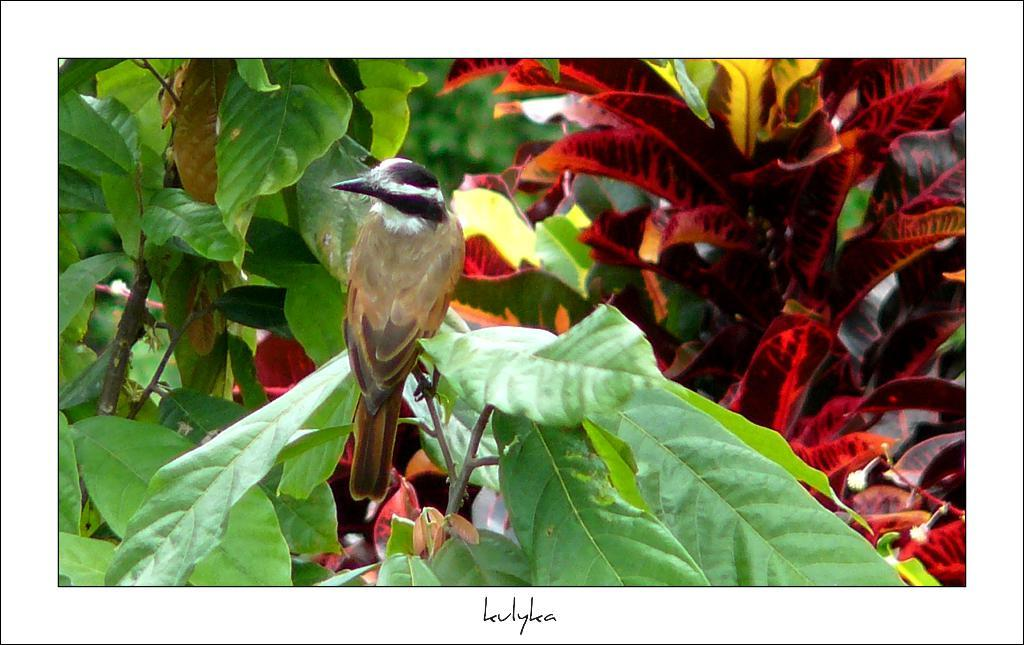What type of animal can be seen in the image? There is a bird in the image. Where is the bird located in the image? The bird is sitting on a plant stem. What else can be seen in the image besides the bird? There are other plants visible in the image. What type of crown is the bird wearing in the image? There is no crown present in the image; the bird is simply sitting on a plant stem. 